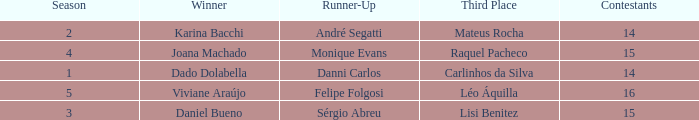In what season was the winner Dado Dolabella? 1.0. 